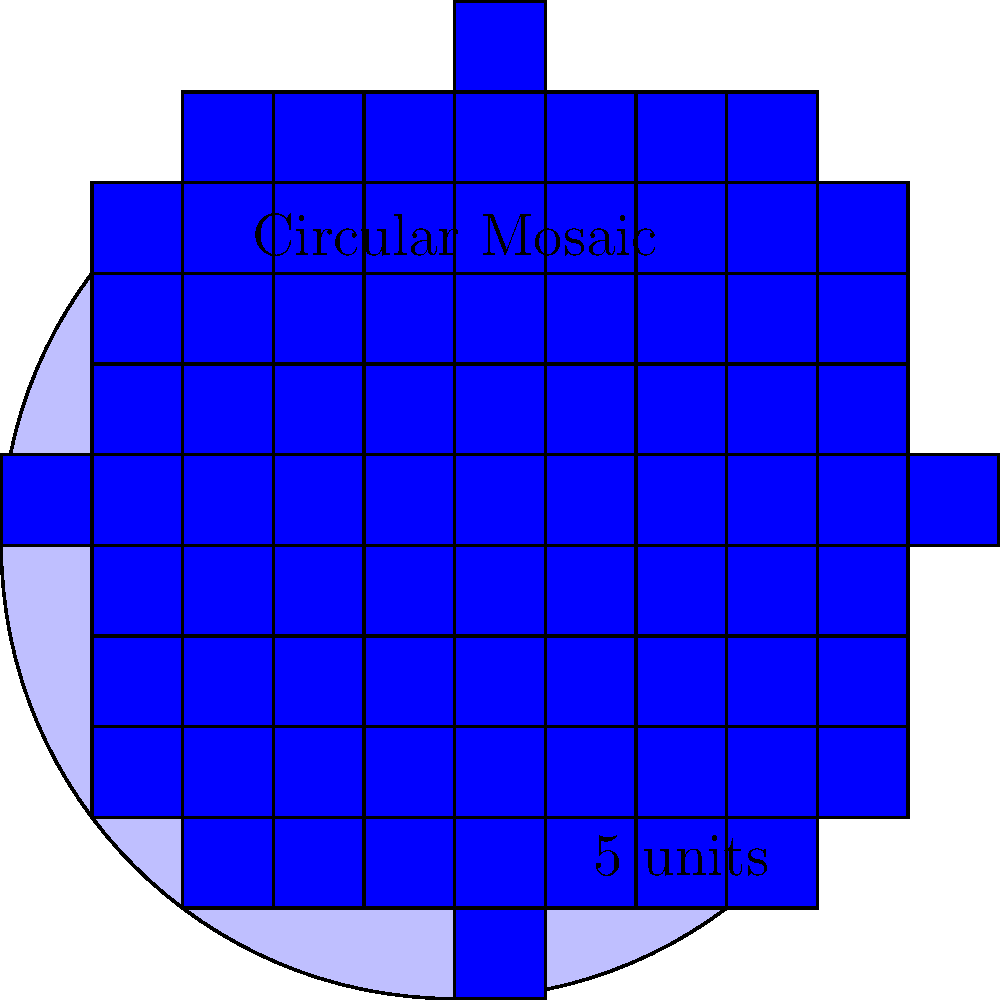You're designing a circular mosaic for your study based on an intricate pattern you discovered during your travels in Morocco. The mosaic will be created using 1-inch square tiles and will have a diameter of 5 feet. Estimate the number of whole tiles needed to complete this mosaic, assuming you'll only use whole tiles (no cutting) and will fill the circular area as completely as possible. To estimate the number of tiles needed, we'll follow these steps:

1) Convert the diameter from feet to inches:
   $5 \text{ feet} = 5 \times 12 = 60 \text{ inches}$

2) Calculate the radius:
   $r = 60 \div 2 = 30 \text{ inches}$

3) Calculate the area of the circular mosaic:
   $A = \pi r^2 = \pi \times 30^2 \approx 2827.43 \text{ square inches}$

4) Since each tile is 1 inch square, the number of tiles needed is approximately equal to the area in square inches.

5) However, we need to account for the fact that we're using whole tiles to fill a circular area. This means we'll have some overhang at the edges.

6) A common estimation method is to use the square of the diameter:
   $5^2 = 25 \text{ square feet} = 25 \times 144 = 3600 \text{ square inches}$

7) This overestimates slightly, but it's a good practical approximation that accounts for the overhang and ensures we have enough tiles.

Therefore, we estimate needing approximately 3600 tiles for the mosaic.
Answer: 3600 tiles 